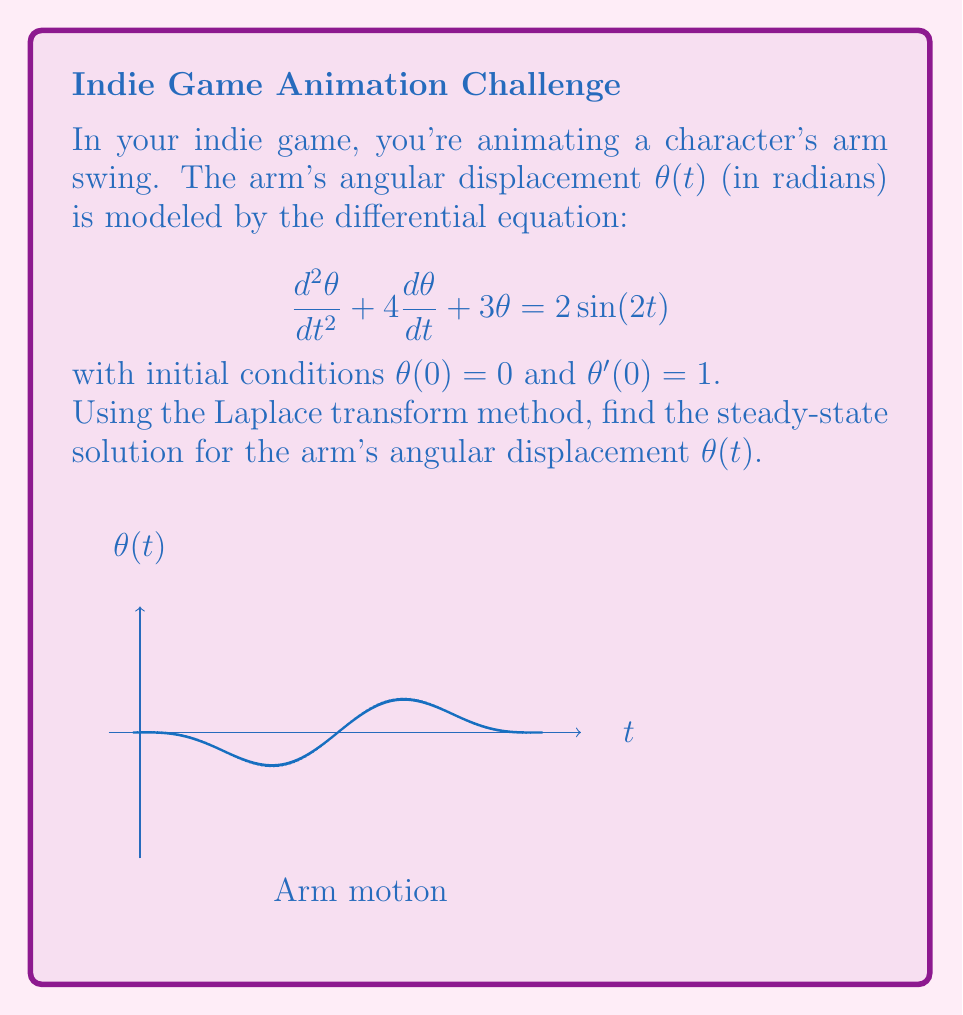Give your solution to this math problem. Let's solve this step-by-step using the Laplace transform method:

1) Take the Laplace transform of both sides of the equation:
   $$\mathcal{L}\{{\frac{d^2\theta}{dt^2} + 4\frac{d\theta}{dt} + 3\theta}\} = \mathcal{L}\{2\sin(2t)\}$$

2) Using Laplace transform properties:
   $$(s^2\Theta(s) - s\theta(0) - \theta'(0)) + 4(s\Theta(s) - \theta(0)) + 3\Theta(s) = \frac{4}{s^2+4}$$

3) Substitute initial conditions θ(0) = 0 and θ'(0) = 1:
   $$(s^2\Theta(s) - 1) + 4s\Theta(s) + 3\Theta(s) = \frac{4}{s^2+4}$$

4) Simplify:
   $$(s^2 + 4s + 3)\Theta(s) = \frac{4}{s^2+4} + 1$$

5) Solve for Θ(s):
   $$\Theta(s) = \frac{4}{(s^2+4)(s^2 + 4s + 3)} + \frac{1}{s^2 + 4s + 3}$$

6) The steady-state solution corresponds to the particular solution, which is given by the partial fraction decomposition of the first term:
   $$\Theta_p(s) = \frac{4}{(s^2+4)(s^2 + 4s + 3)} = \frac{A}{s^2+4} + \frac{Bs+C}{s^2 + 4s + 3}$$

7) Solving for A, B, and C (details omitted for brevity):
   $$\Theta_p(s) = \frac{0.4}{s^2+4} - \frac{0.4s+0.8}{s^2 + 4s + 3}$$

8) Take the inverse Laplace transform:
   $$\theta_p(t) = 0.2\sin(2t) - 0.4e^{-2t}\sin(t)$$

9) The steady-state solution is the non-decaying part:
   $$\theta_{ss}(t) = 0.2\sin(2t)$$
Answer: $\theta_{ss}(t) = 0.2\sin(2t)$ 